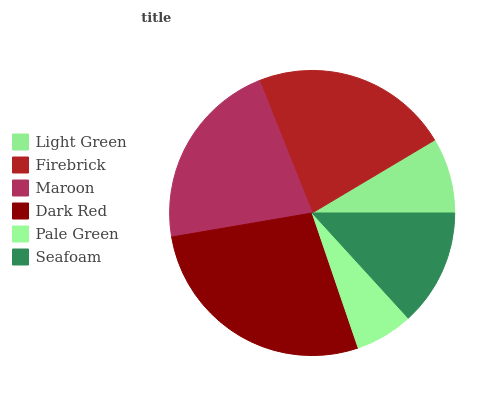Is Pale Green the minimum?
Answer yes or no. Yes. Is Dark Red the maximum?
Answer yes or no. Yes. Is Firebrick the minimum?
Answer yes or no. No. Is Firebrick the maximum?
Answer yes or no. No. Is Firebrick greater than Light Green?
Answer yes or no. Yes. Is Light Green less than Firebrick?
Answer yes or no. Yes. Is Light Green greater than Firebrick?
Answer yes or no. No. Is Firebrick less than Light Green?
Answer yes or no. No. Is Maroon the high median?
Answer yes or no. Yes. Is Seafoam the low median?
Answer yes or no. Yes. Is Seafoam the high median?
Answer yes or no. No. Is Firebrick the low median?
Answer yes or no. No. 